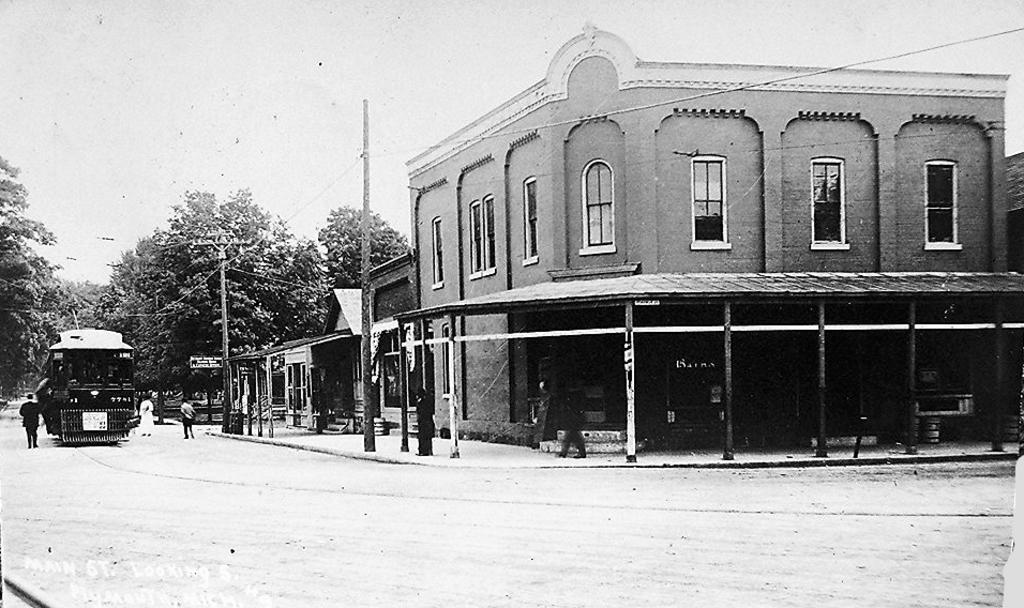How would you summarize this image in a sentence or two? This is a black and white image, we can see ground, a few people, vehicle, trees, poles, wires, building, shed, and the sky. 